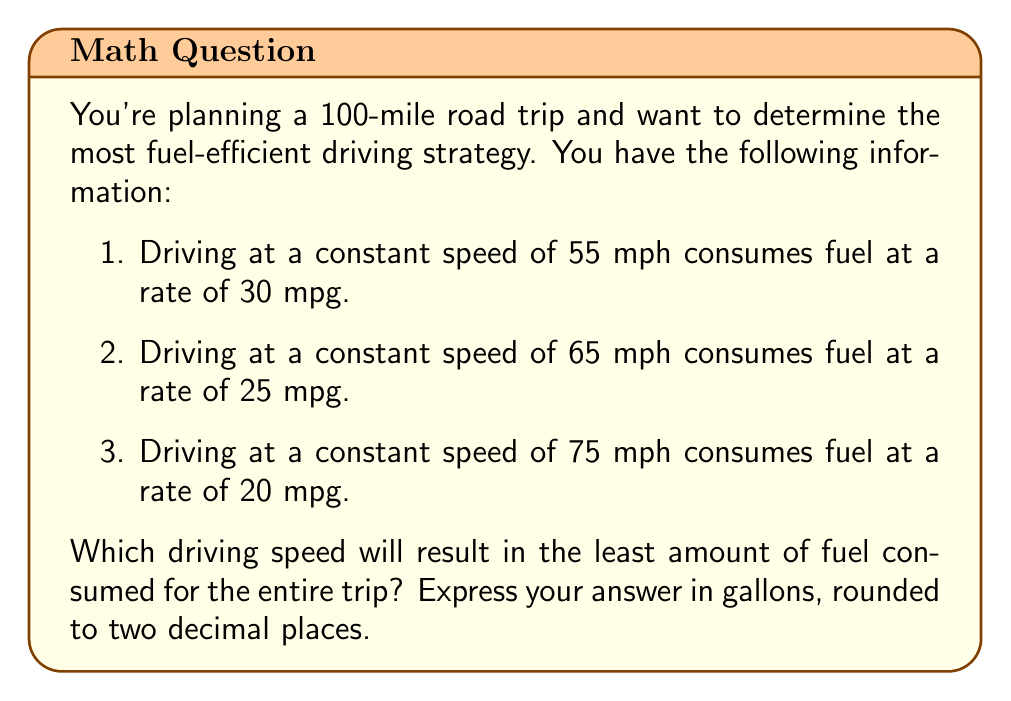Teach me how to tackle this problem. To solve this problem, we need to calculate the amount of fuel consumed for each driving speed over the 100-mile trip. We'll use the formula:

$$ \text{Fuel Consumed} = \frac{\text{Distance}}{\text{Miles per Gallon}} $$

Let's calculate for each speed:

1. For 55 mph:
   $$ \text{Fuel Consumed} = \frac{100 \text{ miles}}{30 \text{ mpg}} = 3.33 \text{ gallons} $$

2. For 65 mph:
   $$ \text{Fuel Consumed} = \frac{100 \text{ miles}}{25 \text{ mpg}} = 4 \text{ gallons} $$

3. For 75 mph:
   $$ \text{Fuel Consumed} = \frac{100 \text{ miles}}{20 \text{ mpg}} = 5 \text{ gallons} $$

Comparing these results, we can see that driving at 55 mph consumes the least amount of fuel (3.33 gallons).

It's worth noting that while driving at a higher speed might save time, it's less fuel-efficient in this scenario. This demonstrates the trade-off between time and fuel efficiency that drivers often face.
Answer: 3.33 gallons 